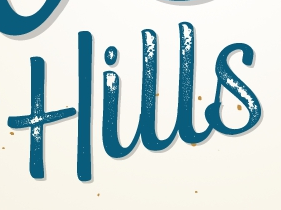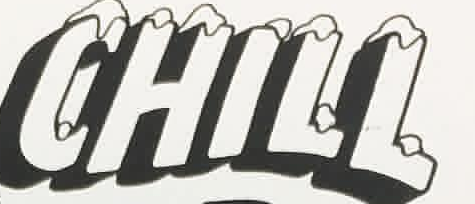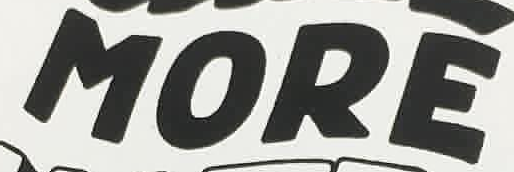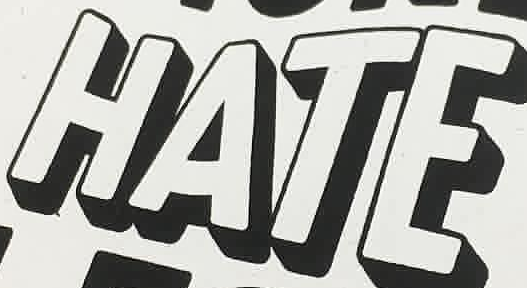Read the text content from these images in order, separated by a semicolon. Hills; CHILL; MORE; HATE 